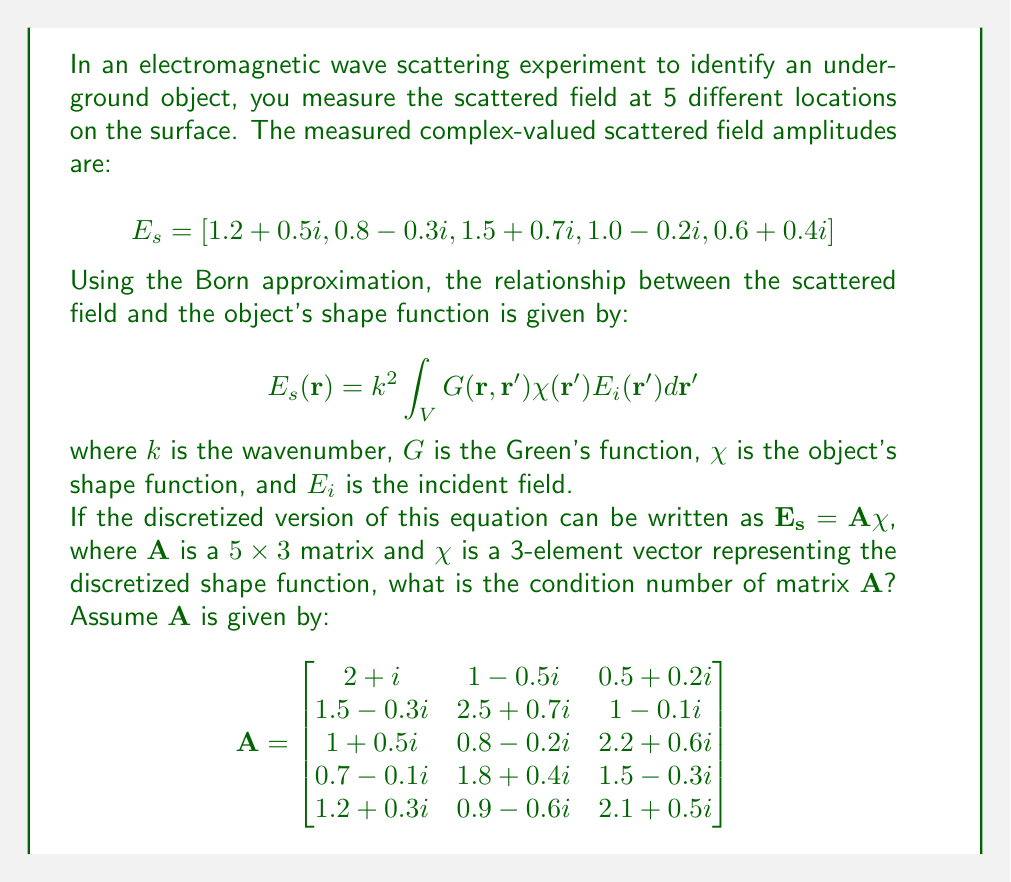What is the answer to this math problem? To solve this problem, we'll follow these steps:

1) Recall that the condition number of a matrix $\mathbf{A}$ is defined as:

   $$\kappa(\mathbf{A}) = \|\mathbf{A}\| \cdot \|\mathbf{A}^{-1}\|$$

   where $\|\cdot\|$ denotes a matrix norm.

2) For this problem, we'll use the 2-norm (spectral norm), which for a matrix is equal to its largest singular value.

3) To find the singular values, we need to compute $\mathbf{A}^H\mathbf{A}$, where $\mathbf{A}^H$ is the conjugate transpose of $\mathbf{A}$.

4) Calculate $\mathbf{A}^H\mathbf{A}$:

   $$\mathbf{A}^H\mathbf{A} = \begin{bmatrix}
   13.59 & 10.97-1.7i & 12.38+0.6i \\
   10.97+1.7i & 14.74 & 11.51-1.1i \\
   12.38-0.6i & 11.51+1.1i & 13.67
   \end{bmatrix}$$

5) Find the eigenvalues of $\mathbf{A}^H\mathbf{A}$. These are approximately:
   
   $\lambda_1 \approx 37.91$
   $\lambda_2 \approx 3.43$
   $\lambda_3 \approx 0.66$

6) The singular values of $\mathbf{A}$ are the square roots of these eigenvalues:
   
   $\sigma_1 \approx 6.16$
   $\sigma_2 \approx 1.85$
   $\sigma_3 \approx 0.81$

7) The condition number is the ratio of the largest to the smallest singular value:

   $$\kappa(\mathbf{A}) = \frac{\sigma_1}{\sigma_3} \approx \frac{6.16}{0.81} \approx 7.60$$

Therefore, the condition number of matrix $\mathbf{A}$ is approximately 7.60.
Answer: 7.60 